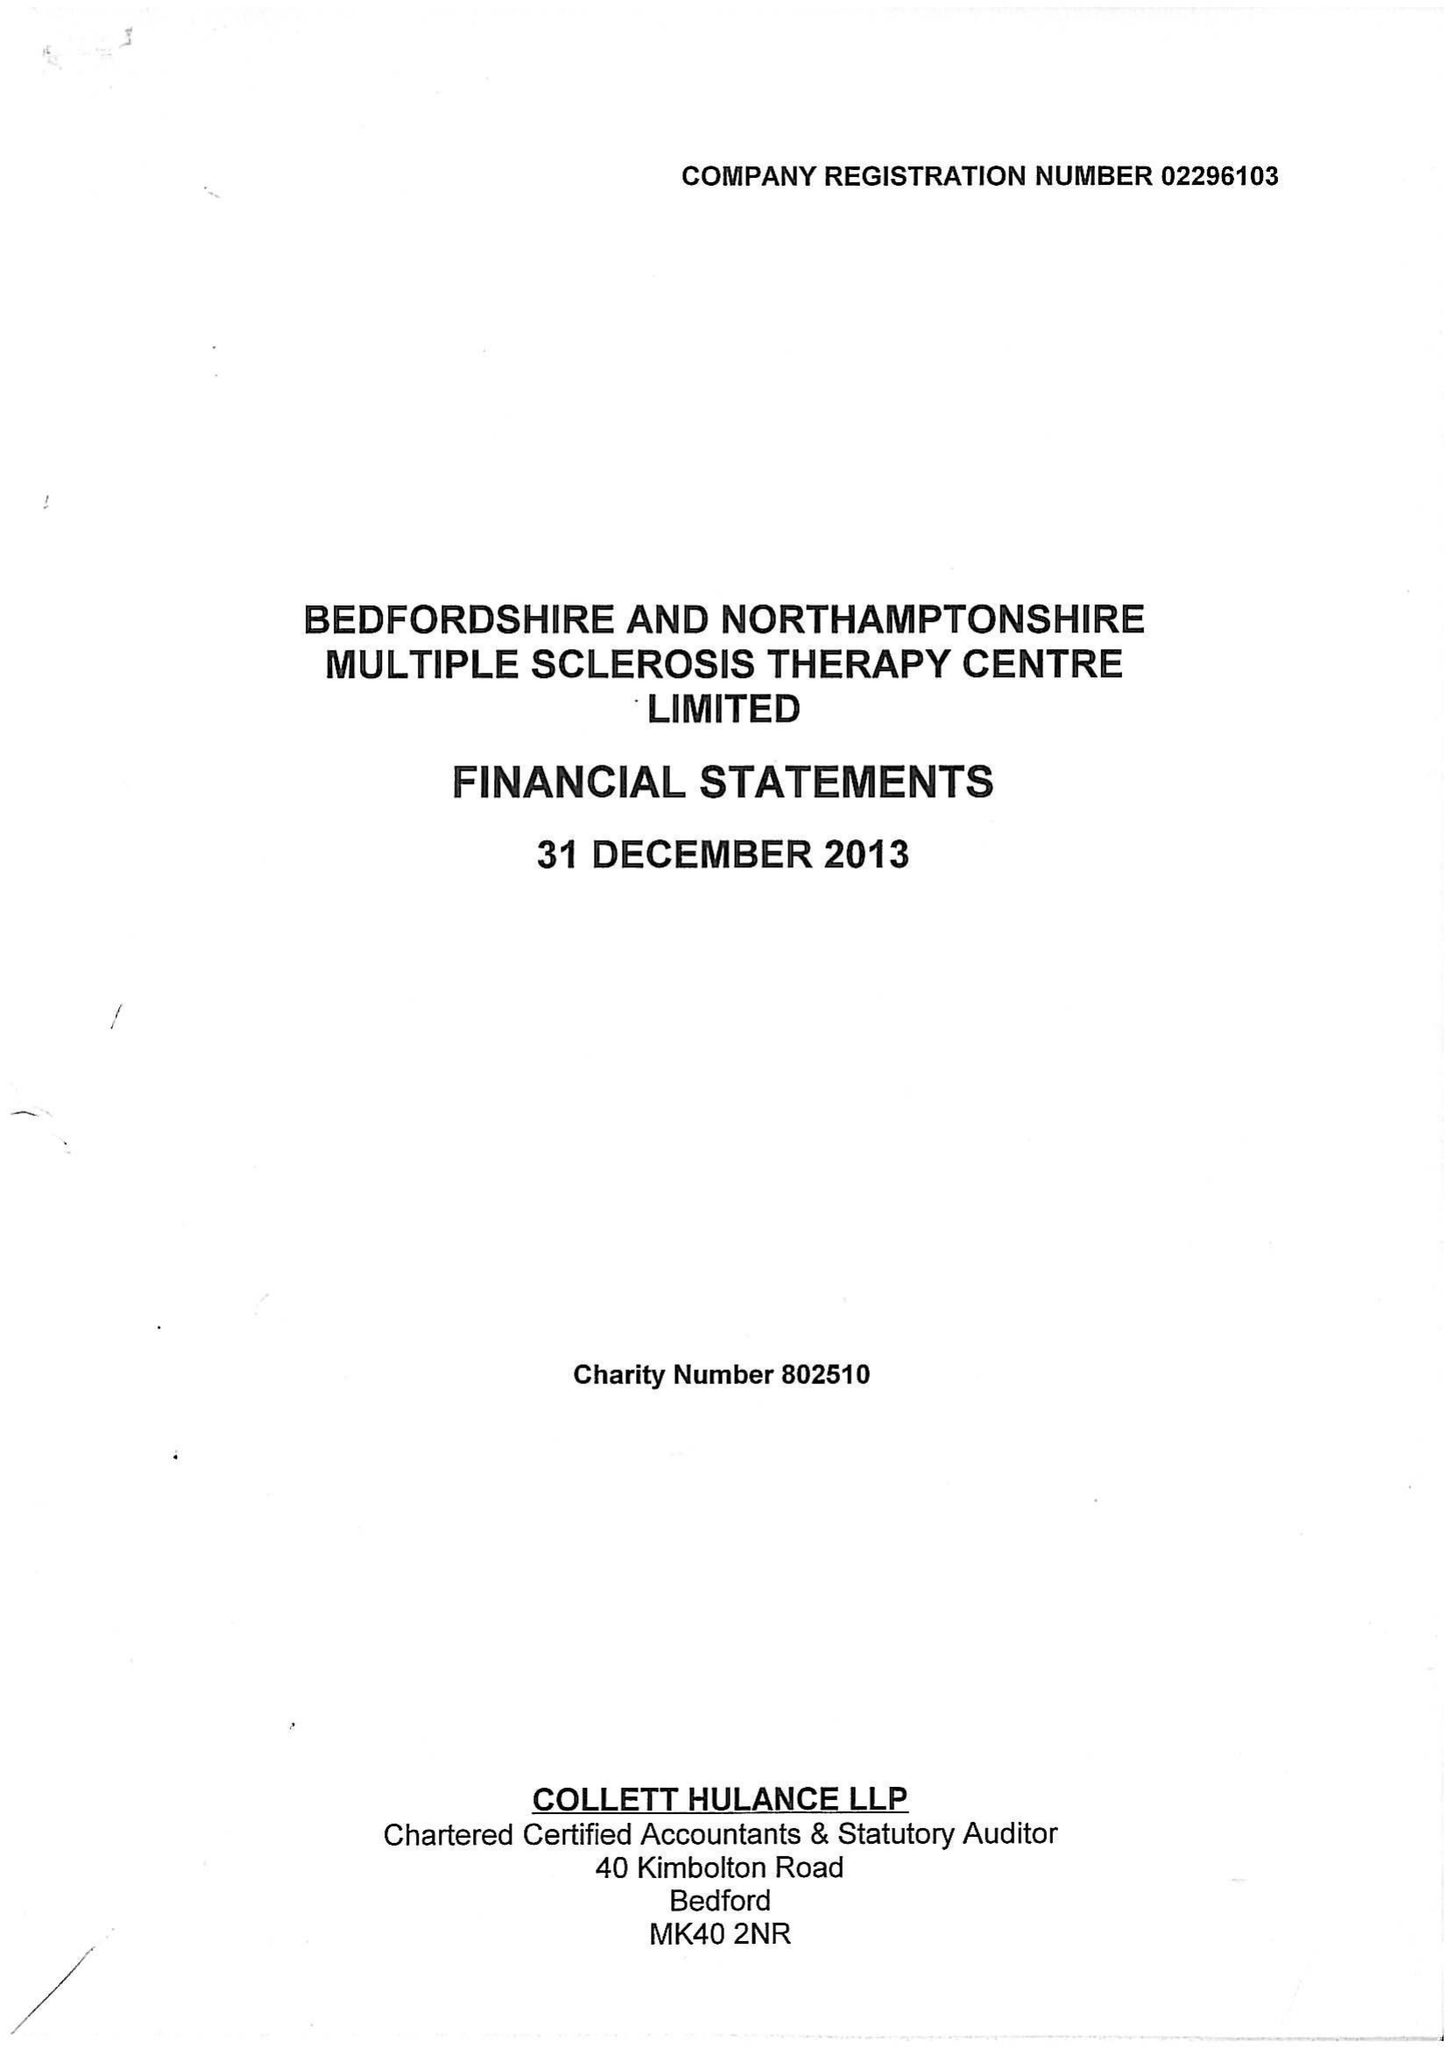What is the value for the income_annually_in_british_pounds?
Answer the question using a single word or phrase. 361299.00 